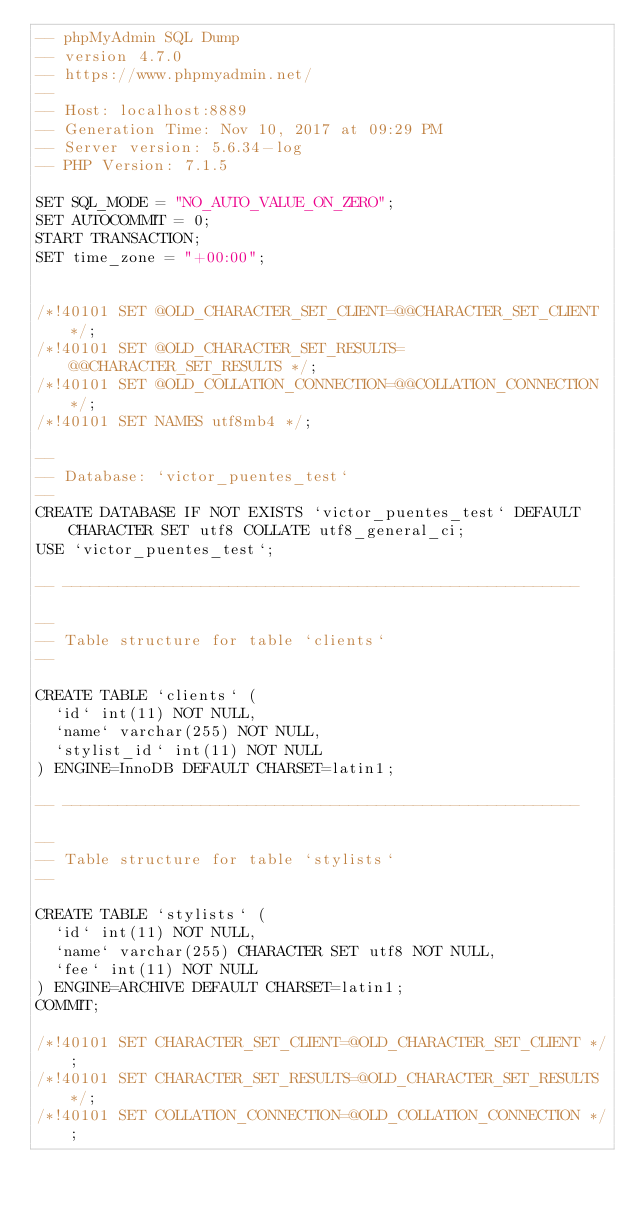<code> <loc_0><loc_0><loc_500><loc_500><_SQL_>-- phpMyAdmin SQL Dump
-- version 4.7.0
-- https://www.phpmyadmin.net/
--
-- Host: localhost:8889
-- Generation Time: Nov 10, 2017 at 09:29 PM
-- Server version: 5.6.34-log
-- PHP Version: 7.1.5

SET SQL_MODE = "NO_AUTO_VALUE_ON_ZERO";
SET AUTOCOMMIT = 0;
START TRANSACTION;
SET time_zone = "+00:00";


/*!40101 SET @OLD_CHARACTER_SET_CLIENT=@@CHARACTER_SET_CLIENT */;
/*!40101 SET @OLD_CHARACTER_SET_RESULTS=@@CHARACTER_SET_RESULTS */;
/*!40101 SET @OLD_COLLATION_CONNECTION=@@COLLATION_CONNECTION */;
/*!40101 SET NAMES utf8mb4 */;

--
-- Database: `victor_puentes_test`
--
CREATE DATABASE IF NOT EXISTS `victor_puentes_test` DEFAULT CHARACTER SET utf8 COLLATE utf8_general_ci;
USE `victor_puentes_test`;

-- --------------------------------------------------------

--
-- Table structure for table `clients`
--

CREATE TABLE `clients` (
  `id` int(11) NOT NULL,
  `name` varchar(255) NOT NULL,
  `stylist_id` int(11) NOT NULL
) ENGINE=InnoDB DEFAULT CHARSET=latin1;

-- --------------------------------------------------------

--
-- Table structure for table `stylists`
--

CREATE TABLE `stylists` (
  `id` int(11) NOT NULL,
  `name` varchar(255) CHARACTER SET utf8 NOT NULL,
  `fee` int(11) NOT NULL
) ENGINE=ARCHIVE DEFAULT CHARSET=latin1;
COMMIT;

/*!40101 SET CHARACTER_SET_CLIENT=@OLD_CHARACTER_SET_CLIENT */;
/*!40101 SET CHARACTER_SET_RESULTS=@OLD_CHARACTER_SET_RESULTS */;
/*!40101 SET COLLATION_CONNECTION=@OLD_COLLATION_CONNECTION */;
</code> 